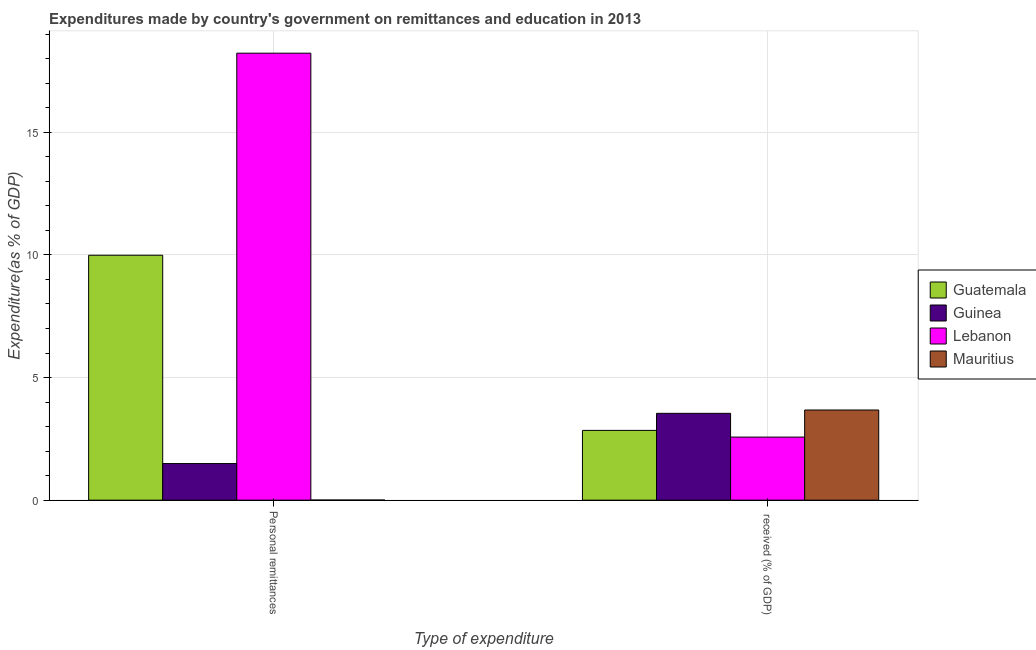How many different coloured bars are there?
Offer a very short reply. 4. Are the number of bars per tick equal to the number of legend labels?
Your answer should be very brief. Yes. How many bars are there on the 1st tick from the left?
Offer a very short reply. 4. How many bars are there on the 2nd tick from the right?
Your answer should be compact. 4. What is the label of the 2nd group of bars from the left?
Ensure brevity in your answer.   received (% of GDP). What is the expenditure in personal remittances in Guatemala?
Provide a short and direct response. 9.99. Across all countries, what is the maximum expenditure in education?
Offer a terse response. 3.68. Across all countries, what is the minimum expenditure in education?
Provide a short and direct response. 2.57. In which country was the expenditure in personal remittances maximum?
Provide a succinct answer. Lebanon. In which country was the expenditure in personal remittances minimum?
Offer a terse response. Mauritius. What is the total expenditure in education in the graph?
Offer a terse response. 12.64. What is the difference between the expenditure in personal remittances in Guinea and that in Lebanon?
Your answer should be very brief. -16.74. What is the difference between the expenditure in education in Guinea and the expenditure in personal remittances in Guatemala?
Offer a terse response. -6.45. What is the average expenditure in personal remittances per country?
Offer a very short reply. 7.43. What is the difference between the expenditure in education and expenditure in personal remittances in Guatemala?
Keep it short and to the point. -7.14. In how many countries, is the expenditure in education greater than 11 %?
Keep it short and to the point. 0. What is the ratio of the expenditure in education in Guinea to that in Lebanon?
Give a very brief answer. 1.38. Is the expenditure in education in Guinea less than that in Lebanon?
Provide a succinct answer. No. In how many countries, is the expenditure in education greater than the average expenditure in education taken over all countries?
Provide a succinct answer. 2. What does the 4th bar from the left in Personal remittances represents?
Make the answer very short. Mauritius. What does the 4th bar from the right in Personal remittances represents?
Provide a short and direct response. Guatemala. How many bars are there?
Your response must be concise. 8. Are all the bars in the graph horizontal?
Keep it short and to the point. No. What is the difference between two consecutive major ticks on the Y-axis?
Offer a terse response. 5. Does the graph contain grids?
Your answer should be very brief. Yes. Where does the legend appear in the graph?
Your answer should be very brief. Center right. How many legend labels are there?
Your response must be concise. 4. What is the title of the graph?
Your response must be concise. Expenditures made by country's government on remittances and education in 2013. What is the label or title of the X-axis?
Ensure brevity in your answer.  Type of expenditure. What is the label or title of the Y-axis?
Make the answer very short. Expenditure(as % of GDP). What is the Expenditure(as % of GDP) of Guatemala in Personal remittances?
Provide a succinct answer. 9.99. What is the Expenditure(as % of GDP) of Guinea in Personal remittances?
Offer a terse response. 1.49. What is the Expenditure(as % of GDP) of Lebanon in Personal remittances?
Offer a very short reply. 18.23. What is the Expenditure(as % of GDP) in Mauritius in Personal remittances?
Make the answer very short. 0. What is the Expenditure(as % of GDP) in Guatemala in  received (% of GDP)?
Offer a terse response. 2.85. What is the Expenditure(as % of GDP) in Guinea in  received (% of GDP)?
Offer a very short reply. 3.54. What is the Expenditure(as % of GDP) in Lebanon in  received (% of GDP)?
Offer a terse response. 2.57. What is the Expenditure(as % of GDP) of Mauritius in  received (% of GDP)?
Offer a terse response. 3.68. Across all Type of expenditure, what is the maximum Expenditure(as % of GDP) of Guatemala?
Make the answer very short. 9.99. Across all Type of expenditure, what is the maximum Expenditure(as % of GDP) in Guinea?
Provide a succinct answer. 3.54. Across all Type of expenditure, what is the maximum Expenditure(as % of GDP) of Lebanon?
Ensure brevity in your answer.  18.23. Across all Type of expenditure, what is the maximum Expenditure(as % of GDP) in Mauritius?
Your response must be concise. 3.68. Across all Type of expenditure, what is the minimum Expenditure(as % of GDP) of Guatemala?
Offer a terse response. 2.85. Across all Type of expenditure, what is the minimum Expenditure(as % of GDP) of Guinea?
Provide a short and direct response. 1.49. Across all Type of expenditure, what is the minimum Expenditure(as % of GDP) of Lebanon?
Your answer should be compact. 2.57. Across all Type of expenditure, what is the minimum Expenditure(as % of GDP) in Mauritius?
Offer a very short reply. 0. What is the total Expenditure(as % of GDP) in Guatemala in the graph?
Offer a terse response. 12.83. What is the total Expenditure(as % of GDP) in Guinea in the graph?
Make the answer very short. 5.03. What is the total Expenditure(as % of GDP) of Lebanon in the graph?
Ensure brevity in your answer.  20.8. What is the total Expenditure(as % of GDP) in Mauritius in the graph?
Your answer should be very brief. 3.68. What is the difference between the Expenditure(as % of GDP) in Guatemala in Personal remittances and that in  received (% of GDP)?
Your response must be concise. 7.14. What is the difference between the Expenditure(as % of GDP) in Guinea in Personal remittances and that in  received (% of GDP)?
Offer a terse response. -2.05. What is the difference between the Expenditure(as % of GDP) of Lebanon in Personal remittances and that in  received (% of GDP)?
Your answer should be compact. 15.66. What is the difference between the Expenditure(as % of GDP) in Mauritius in Personal remittances and that in  received (% of GDP)?
Give a very brief answer. -3.67. What is the difference between the Expenditure(as % of GDP) in Guatemala in Personal remittances and the Expenditure(as % of GDP) in Guinea in  received (% of GDP)?
Make the answer very short. 6.45. What is the difference between the Expenditure(as % of GDP) in Guatemala in Personal remittances and the Expenditure(as % of GDP) in Lebanon in  received (% of GDP)?
Your response must be concise. 7.42. What is the difference between the Expenditure(as % of GDP) of Guatemala in Personal remittances and the Expenditure(as % of GDP) of Mauritius in  received (% of GDP)?
Make the answer very short. 6.31. What is the difference between the Expenditure(as % of GDP) of Guinea in Personal remittances and the Expenditure(as % of GDP) of Lebanon in  received (% of GDP)?
Your response must be concise. -1.08. What is the difference between the Expenditure(as % of GDP) in Guinea in Personal remittances and the Expenditure(as % of GDP) in Mauritius in  received (% of GDP)?
Keep it short and to the point. -2.18. What is the difference between the Expenditure(as % of GDP) of Lebanon in Personal remittances and the Expenditure(as % of GDP) of Mauritius in  received (% of GDP)?
Keep it short and to the point. 14.55. What is the average Expenditure(as % of GDP) in Guatemala per Type of expenditure?
Make the answer very short. 6.42. What is the average Expenditure(as % of GDP) of Guinea per Type of expenditure?
Provide a succinct answer. 2.52. What is the average Expenditure(as % of GDP) in Lebanon per Type of expenditure?
Ensure brevity in your answer.  10.4. What is the average Expenditure(as % of GDP) of Mauritius per Type of expenditure?
Keep it short and to the point. 1.84. What is the difference between the Expenditure(as % of GDP) in Guatemala and Expenditure(as % of GDP) in Guinea in Personal remittances?
Provide a succinct answer. 8.5. What is the difference between the Expenditure(as % of GDP) in Guatemala and Expenditure(as % of GDP) in Lebanon in Personal remittances?
Make the answer very short. -8.24. What is the difference between the Expenditure(as % of GDP) of Guatemala and Expenditure(as % of GDP) of Mauritius in Personal remittances?
Offer a very short reply. 9.98. What is the difference between the Expenditure(as % of GDP) of Guinea and Expenditure(as % of GDP) of Lebanon in Personal remittances?
Ensure brevity in your answer.  -16.74. What is the difference between the Expenditure(as % of GDP) in Guinea and Expenditure(as % of GDP) in Mauritius in Personal remittances?
Provide a short and direct response. 1.49. What is the difference between the Expenditure(as % of GDP) of Lebanon and Expenditure(as % of GDP) of Mauritius in Personal remittances?
Give a very brief answer. 18.22. What is the difference between the Expenditure(as % of GDP) in Guatemala and Expenditure(as % of GDP) in Guinea in  received (% of GDP)?
Provide a short and direct response. -0.7. What is the difference between the Expenditure(as % of GDP) in Guatemala and Expenditure(as % of GDP) in Lebanon in  received (% of GDP)?
Your answer should be compact. 0.27. What is the difference between the Expenditure(as % of GDP) in Guatemala and Expenditure(as % of GDP) in Mauritius in  received (% of GDP)?
Provide a succinct answer. -0.83. What is the difference between the Expenditure(as % of GDP) of Guinea and Expenditure(as % of GDP) of Lebanon in  received (% of GDP)?
Make the answer very short. 0.97. What is the difference between the Expenditure(as % of GDP) in Guinea and Expenditure(as % of GDP) in Mauritius in  received (% of GDP)?
Your answer should be very brief. -0.14. What is the difference between the Expenditure(as % of GDP) of Lebanon and Expenditure(as % of GDP) of Mauritius in  received (% of GDP)?
Provide a short and direct response. -1.1. What is the ratio of the Expenditure(as % of GDP) in Guatemala in Personal remittances to that in  received (% of GDP)?
Provide a succinct answer. 3.51. What is the ratio of the Expenditure(as % of GDP) in Guinea in Personal remittances to that in  received (% of GDP)?
Your answer should be compact. 0.42. What is the ratio of the Expenditure(as % of GDP) in Lebanon in Personal remittances to that in  received (% of GDP)?
Offer a very short reply. 7.09. What is the ratio of the Expenditure(as % of GDP) of Mauritius in Personal remittances to that in  received (% of GDP)?
Ensure brevity in your answer.  0. What is the difference between the highest and the second highest Expenditure(as % of GDP) of Guatemala?
Provide a succinct answer. 7.14. What is the difference between the highest and the second highest Expenditure(as % of GDP) in Guinea?
Your response must be concise. 2.05. What is the difference between the highest and the second highest Expenditure(as % of GDP) in Lebanon?
Provide a succinct answer. 15.66. What is the difference between the highest and the second highest Expenditure(as % of GDP) of Mauritius?
Keep it short and to the point. 3.67. What is the difference between the highest and the lowest Expenditure(as % of GDP) in Guatemala?
Keep it short and to the point. 7.14. What is the difference between the highest and the lowest Expenditure(as % of GDP) of Guinea?
Provide a succinct answer. 2.05. What is the difference between the highest and the lowest Expenditure(as % of GDP) in Lebanon?
Your answer should be compact. 15.66. What is the difference between the highest and the lowest Expenditure(as % of GDP) of Mauritius?
Provide a short and direct response. 3.67. 